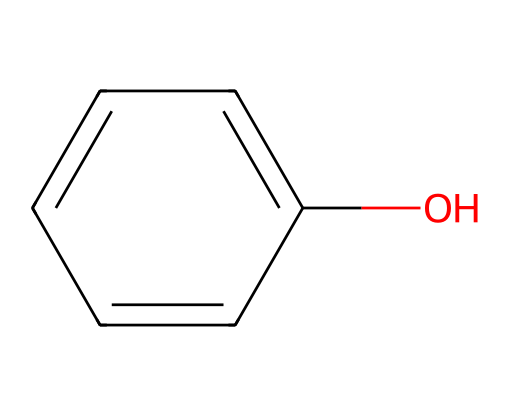what is the name of this chemical? The SMILES representation c1ccccc1O corresponds to a compound with a benzene ring (indicated by the "c" characters) and a hydroxyl group (-OH) attached to it. This structure is recognized as phenol.
Answer: phenol how many carbon atoms are in this molecule? The SMILES notation shows a six-membered aromatic ring made of carbon atoms, as indicated by the six "c" characters. Therefore, there are six carbon atoms present in the molecule.
Answer: six how many hydrogen atoms are connected to the carbon atoms in phenol? Each of the five carbon atoms in the ring is connected to one hydrogen atom, and the carbon atom bonded to the hydroxyl group is connected to one less hydrogen. Thus, the total is 5 + 0 = 5 hydrogen atoms.
Answer: five what is the functional group present in phenol? The presence of the -OH group attached to the aromatic carbon structure identifies the functional group of this compound, which is characteristic of alcohols and, specifically, phenols.
Answer: hydroxyl what property makes phenol suitable for use as a disinfectant? Due to its ability to disrupt cell membranes and denature proteins, phenol's antiseptic properties stem from the hydroxyl group which contributes to its effectiveness against bacteria and viruses.
Answer: antiseptic properties how does the structure of phenol contribute to its disinfectant properties? The planar structure of phenol allows it to penetrate cell membranes effectively, while the hydroxyl group enhances its hydrogen bonding capabilities, allowing it to act powerfully against microbial structures.
Answer: penetrates cell membranes what type of compound is phenol classified as? Phenol is classified as an aromatic compound due to its stable ring structure and the presence of alternating double bonds within the benzene ring, which fulfills the criteria for aromaticity.
Answer: aromatic compound 